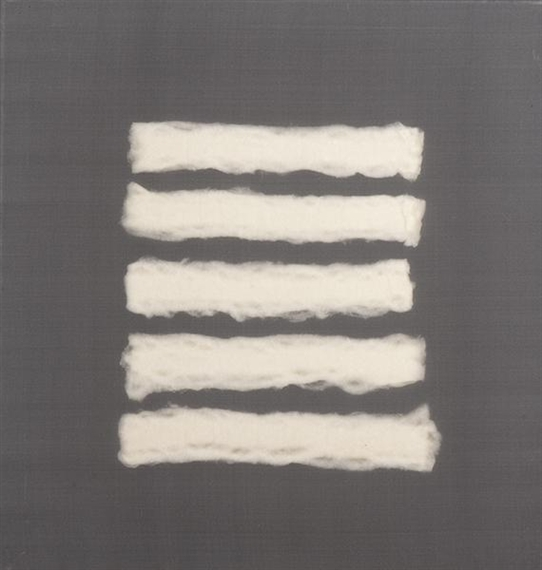Could you describe what materials might have been used in this artwork? The artwork appears to feature white strips that resemble pieces of cotton or wool, placed against a smooth, gray canvas background. The texture and unevenness of the strips suggest they might have been manipulated by hand, perhaps rolled or stretched to create their distinctive form. The canvas itself may be composed of linen or another durable fabric, providing a subtle textured backdrop that contrasts with the softness of the white strips. This combination of materials lends the piece a tactile as well as a visual depth, inviting viewers to consider both its aesthetic and textural composition. 